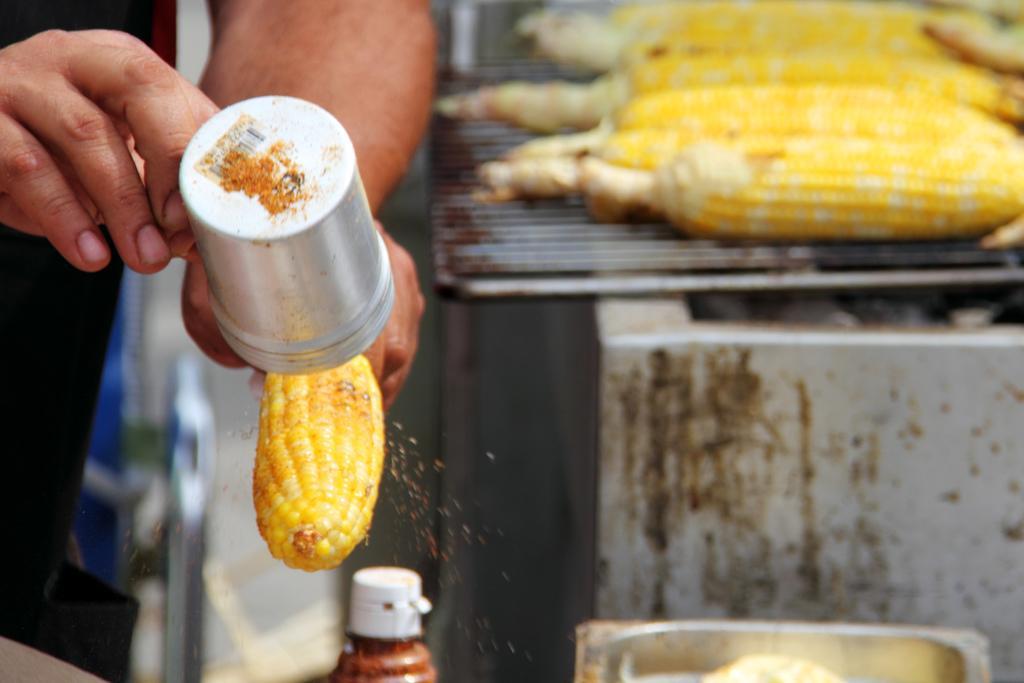In one or two sentences, can you explain what this image depicts? In this image we can see there is a person standing and holding an object. At the back there is a wall, on the wall there is a grill and some food items. And at the back it looks like a blur. 